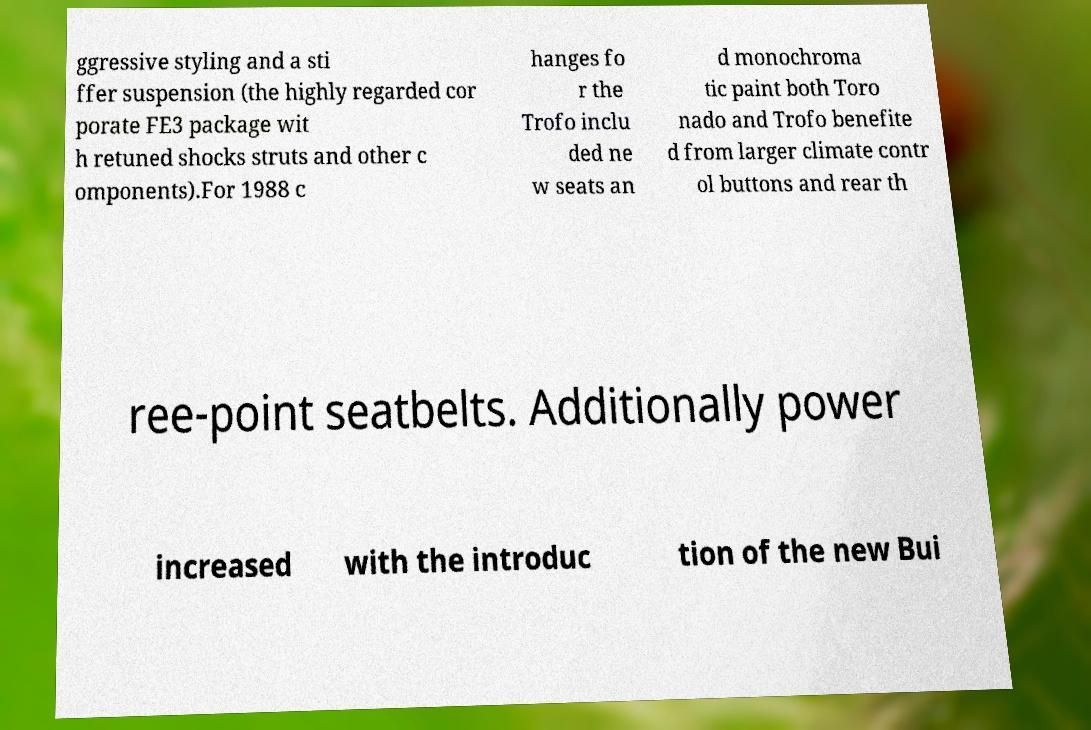For documentation purposes, I need the text within this image transcribed. Could you provide that? ggressive styling and a sti ffer suspension (the highly regarded cor porate FE3 package wit h retuned shocks struts and other c omponents).For 1988 c hanges fo r the Trofo inclu ded ne w seats an d monochroma tic paint both Toro nado and Trofo benefite d from larger climate contr ol buttons and rear th ree-point seatbelts. Additionally power increased with the introduc tion of the new Bui 